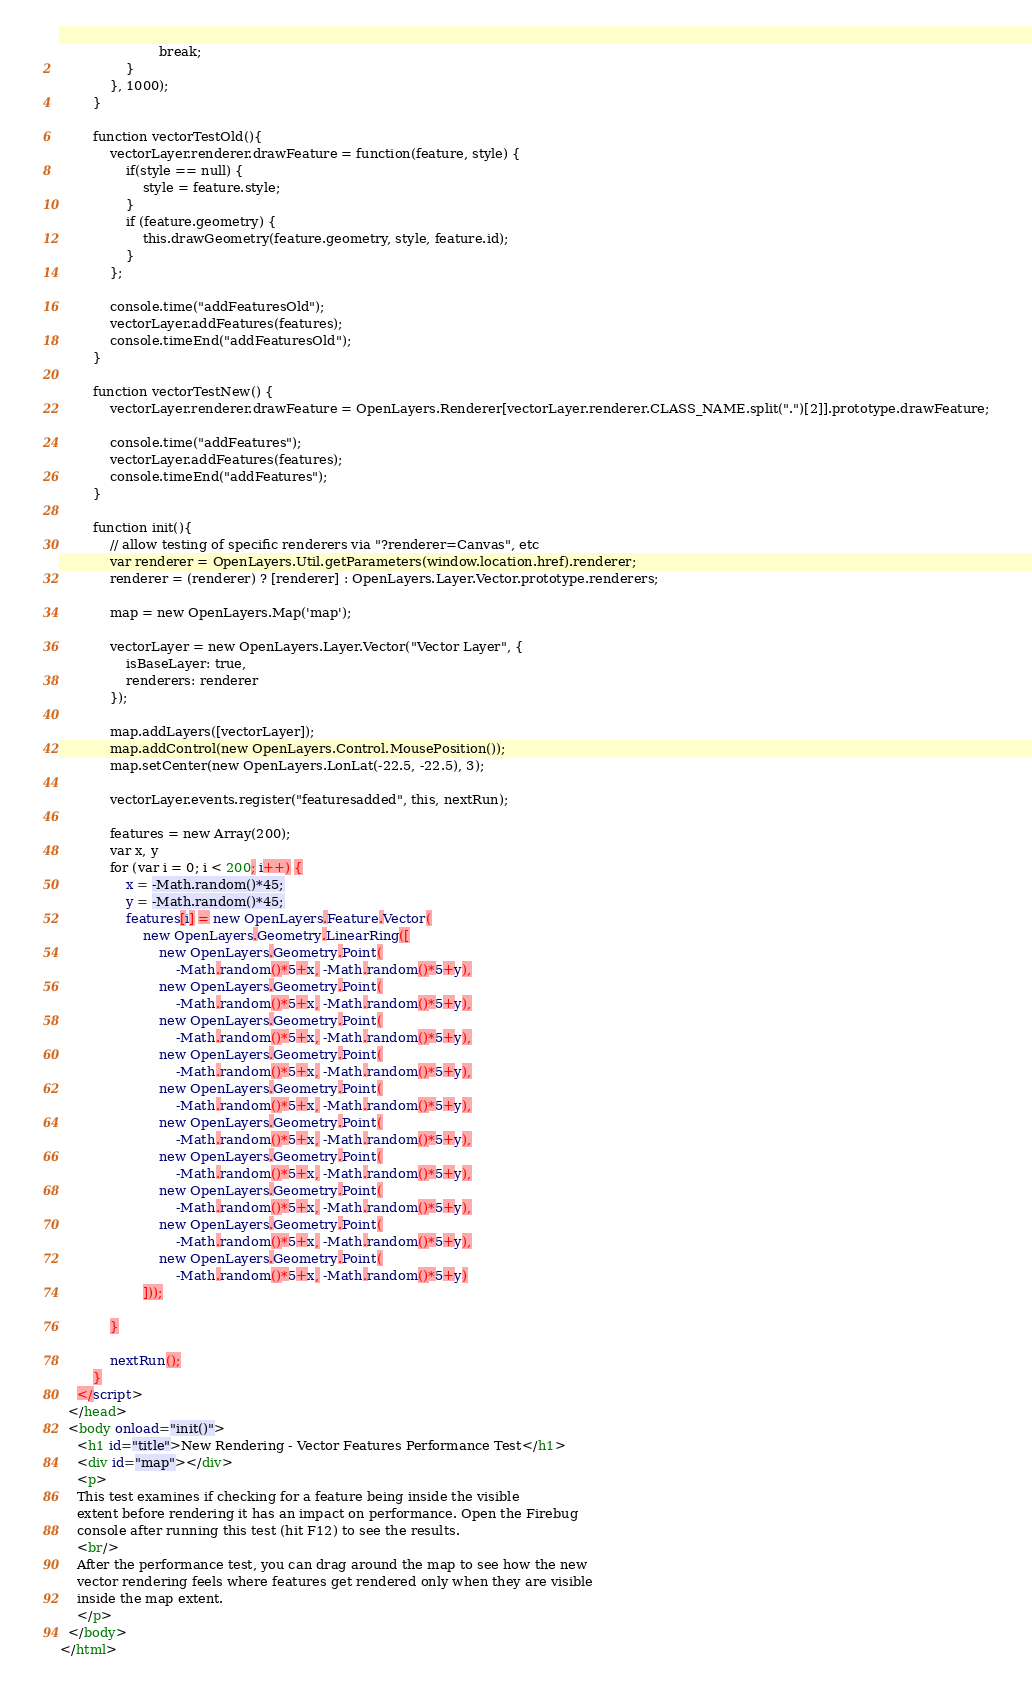<code> <loc_0><loc_0><loc_500><loc_500><_HTML_>                        break;
                }
            }, 1000);
        }
        
        function vectorTestOld(){            
            vectorLayer.renderer.drawFeature = function(feature, style) {
                if(style == null) {
                    style = feature.style;
                }
                if (feature.geometry) {
                    this.drawGeometry(feature.geometry, style, feature.id);
                }
            };

            console.time("addFeaturesOld");
            vectorLayer.addFeatures(features);
            console.timeEnd("addFeaturesOld");
        }
        
        function vectorTestNew() {
            vectorLayer.renderer.drawFeature = OpenLayers.Renderer[vectorLayer.renderer.CLASS_NAME.split(".")[2]].prototype.drawFeature;
            
            console.time("addFeatures");
            vectorLayer.addFeatures(features);
            console.timeEnd("addFeatures");
        }

        function init(){
            // allow testing of specific renderers via "?renderer=Canvas", etc
            var renderer = OpenLayers.Util.getParameters(window.location.href).renderer;
            renderer = (renderer) ? [renderer] : OpenLayers.Layer.Vector.prototype.renderers;

            map = new OpenLayers.Map('map');
            
            vectorLayer = new OpenLayers.Layer.Vector("Vector Layer", {
                isBaseLayer: true,
                renderers: renderer
            });

            map.addLayers([vectorLayer]);
            map.addControl(new OpenLayers.Control.MousePosition());
            map.setCenter(new OpenLayers.LonLat(-22.5, -22.5), 3);

            vectorLayer.events.register("featuresadded", this, nextRun);
            
            features = new Array(200);
            var x, y
            for (var i = 0; i < 200; i++) {
                x = -Math.random()*45;
                y = -Math.random()*45;
                features[i] = new OpenLayers.Feature.Vector(
                    new OpenLayers.Geometry.LinearRing([
                        new OpenLayers.Geometry.Point(
                            -Math.random()*5+x, -Math.random()*5+y),
                        new OpenLayers.Geometry.Point(
                            -Math.random()*5+x, -Math.random()*5+y),
                        new OpenLayers.Geometry.Point(
                            -Math.random()*5+x, -Math.random()*5+y),
                        new OpenLayers.Geometry.Point(
                            -Math.random()*5+x, -Math.random()*5+y),
                        new OpenLayers.Geometry.Point(
                            -Math.random()*5+x, -Math.random()*5+y),
                        new OpenLayers.Geometry.Point(
                            -Math.random()*5+x, -Math.random()*5+y),
                        new OpenLayers.Geometry.Point(
                            -Math.random()*5+x, -Math.random()*5+y),
                        new OpenLayers.Geometry.Point(
                            -Math.random()*5+x, -Math.random()*5+y),
                        new OpenLayers.Geometry.Point(
                            -Math.random()*5+x, -Math.random()*5+y),
                        new OpenLayers.Geometry.Point(
                            -Math.random()*5+x, -Math.random()*5+y)
                    ]));
                    
            }
            
            nextRun();
        }
    </script>
  </head>
  <body onload="init()">
    <h1 id="title">New Rendering - Vector Features Performance Test</h1>
    <div id="map"></div>
    <p>
    This test examines if checking for a feature being inside the visible
    extent before rendering it has an impact on performance. Open the Firebug
    console after running this test (hit F12) to see the results.
    <br/>
    After the performance test, you can drag around the map to see how the new
    vector rendering feels where features get rendered only when they are visible
    inside the map extent. 
    </p>
  </body>
</html>
</code> 